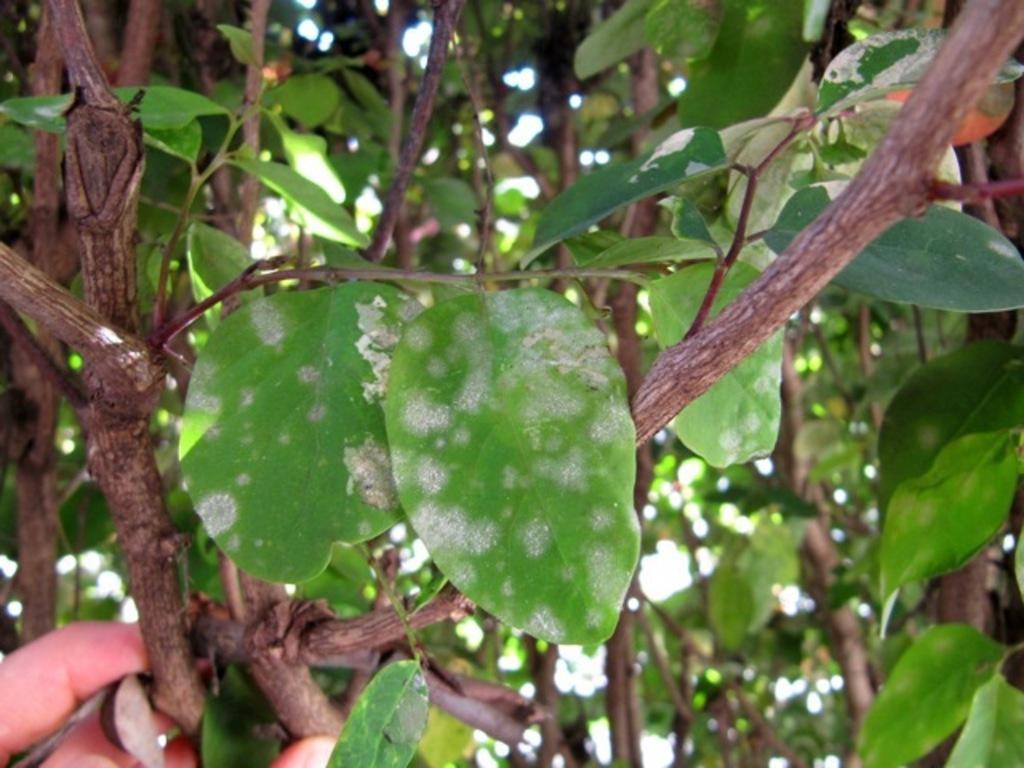Can you describe this image briefly? At the bottom left side of the image, we can see the fingers of a person is holding a branch. In the center of the image, we can see branches with leaves. In the background, we can see trees. 